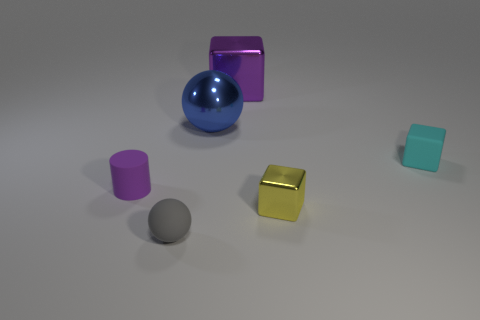What colors do the objects in this image have, and how could they affect the overall aesthetic? The objects present a palette of colors including a reflective silver for the large block, vibrant blue for the sphere, pastel pink and purple for two of the cylinders, a mustard yellow for the cube, and light teal for the small block. These colors create a modern and playful aesthetic, likely conveying a sense of creativity or possibly a setting for conceptual design purposes. 